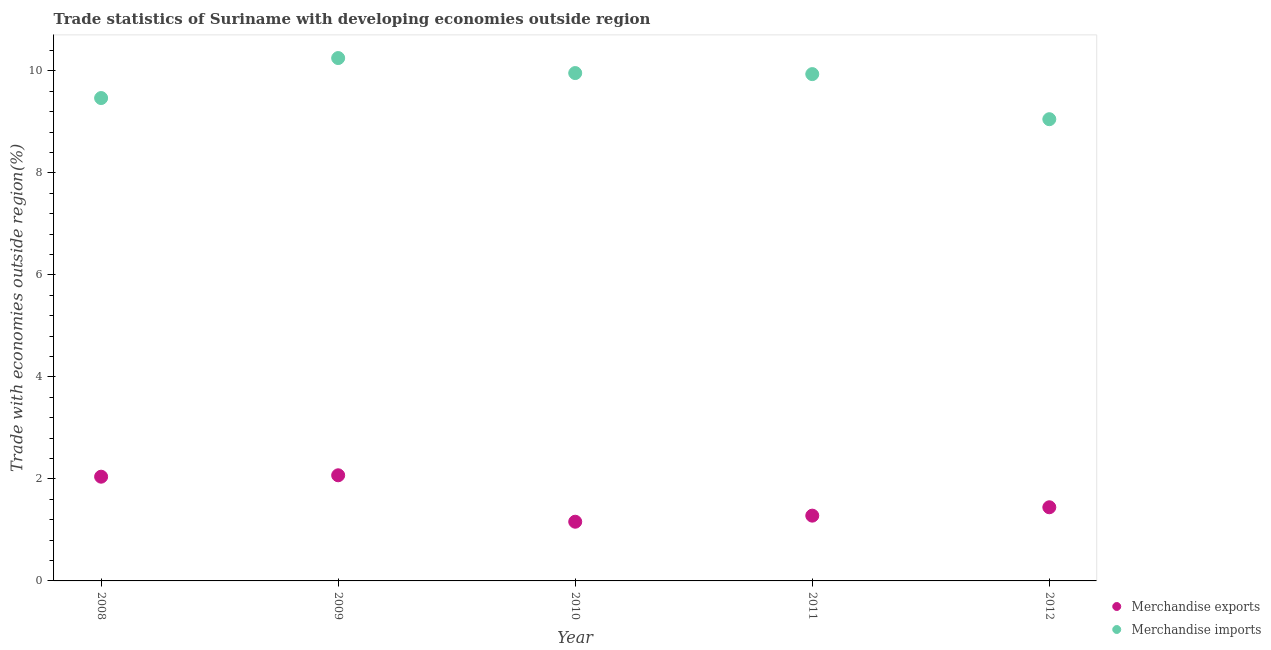How many different coloured dotlines are there?
Offer a terse response. 2. Is the number of dotlines equal to the number of legend labels?
Keep it short and to the point. Yes. What is the merchandise imports in 2009?
Ensure brevity in your answer.  10.25. Across all years, what is the maximum merchandise exports?
Provide a succinct answer. 2.07. Across all years, what is the minimum merchandise imports?
Ensure brevity in your answer.  9.05. In which year was the merchandise imports maximum?
Keep it short and to the point. 2009. What is the total merchandise imports in the graph?
Your answer should be very brief. 48.67. What is the difference between the merchandise imports in 2009 and that in 2011?
Your answer should be very brief. 0.31. What is the difference between the merchandise exports in 2011 and the merchandise imports in 2008?
Your answer should be compact. -8.19. What is the average merchandise exports per year?
Your response must be concise. 1.6. In the year 2010, what is the difference between the merchandise exports and merchandise imports?
Your response must be concise. -8.8. In how many years, is the merchandise imports greater than 6.8 %?
Give a very brief answer. 5. What is the ratio of the merchandise exports in 2009 to that in 2010?
Give a very brief answer. 1.78. What is the difference between the highest and the second highest merchandise imports?
Keep it short and to the point. 0.29. What is the difference between the highest and the lowest merchandise imports?
Provide a succinct answer. 1.2. In how many years, is the merchandise exports greater than the average merchandise exports taken over all years?
Offer a terse response. 2. Are the values on the major ticks of Y-axis written in scientific E-notation?
Provide a short and direct response. No. Does the graph contain any zero values?
Your answer should be compact. No. How many legend labels are there?
Give a very brief answer. 2. What is the title of the graph?
Your answer should be very brief. Trade statistics of Suriname with developing economies outside region. What is the label or title of the X-axis?
Provide a succinct answer. Year. What is the label or title of the Y-axis?
Provide a succinct answer. Trade with economies outside region(%). What is the Trade with economies outside region(%) of Merchandise exports in 2008?
Ensure brevity in your answer.  2.04. What is the Trade with economies outside region(%) of Merchandise imports in 2008?
Your response must be concise. 9.47. What is the Trade with economies outside region(%) of Merchandise exports in 2009?
Ensure brevity in your answer.  2.07. What is the Trade with economies outside region(%) in Merchandise imports in 2009?
Your answer should be very brief. 10.25. What is the Trade with economies outside region(%) of Merchandise exports in 2010?
Give a very brief answer. 1.16. What is the Trade with economies outside region(%) in Merchandise imports in 2010?
Provide a short and direct response. 9.96. What is the Trade with economies outside region(%) in Merchandise exports in 2011?
Your answer should be compact. 1.28. What is the Trade with economies outside region(%) in Merchandise imports in 2011?
Provide a succinct answer. 9.94. What is the Trade with economies outside region(%) in Merchandise exports in 2012?
Provide a succinct answer. 1.44. What is the Trade with economies outside region(%) in Merchandise imports in 2012?
Your answer should be compact. 9.05. Across all years, what is the maximum Trade with economies outside region(%) of Merchandise exports?
Provide a succinct answer. 2.07. Across all years, what is the maximum Trade with economies outside region(%) of Merchandise imports?
Your answer should be compact. 10.25. Across all years, what is the minimum Trade with economies outside region(%) of Merchandise exports?
Your response must be concise. 1.16. Across all years, what is the minimum Trade with economies outside region(%) of Merchandise imports?
Give a very brief answer. 9.05. What is the total Trade with economies outside region(%) of Merchandise exports in the graph?
Provide a succinct answer. 8. What is the total Trade with economies outside region(%) of Merchandise imports in the graph?
Ensure brevity in your answer.  48.67. What is the difference between the Trade with economies outside region(%) in Merchandise exports in 2008 and that in 2009?
Offer a terse response. -0.03. What is the difference between the Trade with economies outside region(%) of Merchandise imports in 2008 and that in 2009?
Ensure brevity in your answer.  -0.78. What is the difference between the Trade with economies outside region(%) of Merchandise exports in 2008 and that in 2010?
Provide a short and direct response. 0.88. What is the difference between the Trade with economies outside region(%) in Merchandise imports in 2008 and that in 2010?
Offer a terse response. -0.49. What is the difference between the Trade with economies outside region(%) of Merchandise exports in 2008 and that in 2011?
Your answer should be very brief. 0.76. What is the difference between the Trade with economies outside region(%) of Merchandise imports in 2008 and that in 2011?
Keep it short and to the point. -0.47. What is the difference between the Trade with economies outside region(%) of Merchandise exports in 2008 and that in 2012?
Offer a very short reply. 0.6. What is the difference between the Trade with economies outside region(%) in Merchandise imports in 2008 and that in 2012?
Your response must be concise. 0.41. What is the difference between the Trade with economies outside region(%) of Merchandise exports in 2009 and that in 2010?
Your response must be concise. 0.91. What is the difference between the Trade with economies outside region(%) of Merchandise imports in 2009 and that in 2010?
Give a very brief answer. 0.29. What is the difference between the Trade with economies outside region(%) of Merchandise exports in 2009 and that in 2011?
Your answer should be compact. 0.79. What is the difference between the Trade with economies outside region(%) in Merchandise imports in 2009 and that in 2011?
Ensure brevity in your answer.  0.31. What is the difference between the Trade with economies outside region(%) in Merchandise exports in 2009 and that in 2012?
Ensure brevity in your answer.  0.63. What is the difference between the Trade with economies outside region(%) in Merchandise imports in 2009 and that in 2012?
Your response must be concise. 1.2. What is the difference between the Trade with economies outside region(%) in Merchandise exports in 2010 and that in 2011?
Ensure brevity in your answer.  -0.12. What is the difference between the Trade with economies outside region(%) of Merchandise imports in 2010 and that in 2011?
Your answer should be very brief. 0.02. What is the difference between the Trade with economies outside region(%) of Merchandise exports in 2010 and that in 2012?
Offer a very short reply. -0.28. What is the difference between the Trade with economies outside region(%) of Merchandise imports in 2010 and that in 2012?
Make the answer very short. 0.9. What is the difference between the Trade with economies outside region(%) of Merchandise exports in 2011 and that in 2012?
Your response must be concise. -0.16. What is the difference between the Trade with economies outside region(%) in Merchandise imports in 2011 and that in 2012?
Your response must be concise. 0.88. What is the difference between the Trade with economies outside region(%) in Merchandise exports in 2008 and the Trade with economies outside region(%) in Merchandise imports in 2009?
Give a very brief answer. -8.21. What is the difference between the Trade with economies outside region(%) of Merchandise exports in 2008 and the Trade with economies outside region(%) of Merchandise imports in 2010?
Keep it short and to the point. -7.91. What is the difference between the Trade with economies outside region(%) in Merchandise exports in 2008 and the Trade with economies outside region(%) in Merchandise imports in 2011?
Offer a very short reply. -7.89. What is the difference between the Trade with economies outside region(%) in Merchandise exports in 2008 and the Trade with economies outside region(%) in Merchandise imports in 2012?
Provide a short and direct response. -7.01. What is the difference between the Trade with economies outside region(%) in Merchandise exports in 2009 and the Trade with economies outside region(%) in Merchandise imports in 2010?
Give a very brief answer. -7.89. What is the difference between the Trade with economies outside region(%) of Merchandise exports in 2009 and the Trade with economies outside region(%) of Merchandise imports in 2011?
Offer a terse response. -7.87. What is the difference between the Trade with economies outside region(%) of Merchandise exports in 2009 and the Trade with economies outside region(%) of Merchandise imports in 2012?
Offer a very short reply. -6.98. What is the difference between the Trade with economies outside region(%) in Merchandise exports in 2010 and the Trade with economies outside region(%) in Merchandise imports in 2011?
Your answer should be compact. -8.78. What is the difference between the Trade with economies outside region(%) of Merchandise exports in 2010 and the Trade with economies outside region(%) of Merchandise imports in 2012?
Make the answer very short. -7.89. What is the difference between the Trade with economies outside region(%) in Merchandise exports in 2011 and the Trade with economies outside region(%) in Merchandise imports in 2012?
Provide a succinct answer. -7.77. What is the average Trade with economies outside region(%) in Merchandise imports per year?
Your response must be concise. 9.73. In the year 2008, what is the difference between the Trade with economies outside region(%) of Merchandise exports and Trade with economies outside region(%) of Merchandise imports?
Your response must be concise. -7.42. In the year 2009, what is the difference between the Trade with economies outside region(%) in Merchandise exports and Trade with economies outside region(%) in Merchandise imports?
Keep it short and to the point. -8.18. In the year 2010, what is the difference between the Trade with economies outside region(%) of Merchandise exports and Trade with economies outside region(%) of Merchandise imports?
Your answer should be very brief. -8.8. In the year 2011, what is the difference between the Trade with economies outside region(%) in Merchandise exports and Trade with economies outside region(%) in Merchandise imports?
Your response must be concise. -8.66. In the year 2012, what is the difference between the Trade with economies outside region(%) in Merchandise exports and Trade with economies outside region(%) in Merchandise imports?
Ensure brevity in your answer.  -7.61. What is the ratio of the Trade with economies outside region(%) of Merchandise exports in 2008 to that in 2009?
Your answer should be compact. 0.99. What is the ratio of the Trade with economies outside region(%) of Merchandise imports in 2008 to that in 2009?
Offer a terse response. 0.92. What is the ratio of the Trade with economies outside region(%) in Merchandise exports in 2008 to that in 2010?
Ensure brevity in your answer.  1.76. What is the ratio of the Trade with economies outside region(%) in Merchandise imports in 2008 to that in 2010?
Ensure brevity in your answer.  0.95. What is the ratio of the Trade with economies outside region(%) of Merchandise exports in 2008 to that in 2011?
Make the answer very short. 1.6. What is the ratio of the Trade with economies outside region(%) of Merchandise imports in 2008 to that in 2011?
Provide a short and direct response. 0.95. What is the ratio of the Trade with economies outside region(%) in Merchandise exports in 2008 to that in 2012?
Keep it short and to the point. 1.42. What is the ratio of the Trade with economies outside region(%) of Merchandise imports in 2008 to that in 2012?
Give a very brief answer. 1.05. What is the ratio of the Trade with economies outside region(%) in Merchandise exports in 2009 to that in 2010?
Ensure brevity in your answer.  1.78. What is the ratio of the Trade with economies outside region(%) of Merchandise imports in 2009 to that in 2010?
Ensure brevity in your answer.  1.03. What is the ratio of the Trade with economies outside region(%) in Merchandise exports in 2009 to that in 2011?
Ensure brevity in your answer.  1.62. What is the ratio of the Trade with economies outside region(%) of Merchandise imports in 2009 to that in 2011?
Give a very brief answer. 1.03. What is the ratio of the Trade with economies outside region(%) in Merchandise exports in 2009 to that in 2012?
Provide a succinct answer. 1.43. What is the ratio of the Trade with economies outside region(%) of Merchandise imports in 2009 to that in 2012?
Make the answer very short. 1.13. What is the ratio of the Trade with economies outside region(%) in Merchandise exports in 2010 to that in 2011?
Your answer should be compact. 0.91. What is the ratio of the Trade with economies outside region(%) in Merchandise imports in 2010 to that in 2011?
Give a very brief answer. 1. What is the ratio of the Trade with economies outside region(%) of Merchandise exports in 2010 to that in 2012?
Offer a very short reply. 0.8. What is the ratio of the Trade with economies outside region(%) in Merchandise imports in 2010 to that in 2012?
Provide a succinct answer. 1.1. What is the ratio of the Trade with economies outside region(%) in Merchandise exports in 2011 to that in 2012?
Provide a short and direct response. 0.89. What is the ratio of the Trade with economies outside region(%) of Merchandise imports in 2011 to that in 2012?
Keep it short and to the point. 1.1. What is the difference between the highest and the second highest Trade with economies outside region(%) in Merchandise exports?
Offer a very short reply. 0.03. What is the difference between the highest and the second highest Trade with economies outside region(%) in Merchandise imports?
Your answer should be very brief. 0.29. What is the difference between the highest and the lowest Trade with economies outside region(%) of Merchandise exports?
Your answer should be very brief. 0.91. What is the difference between the highest and the lowest Trade with economies outside region(%) of Merchandise imports?
Offer a very short reply. 1.2. 